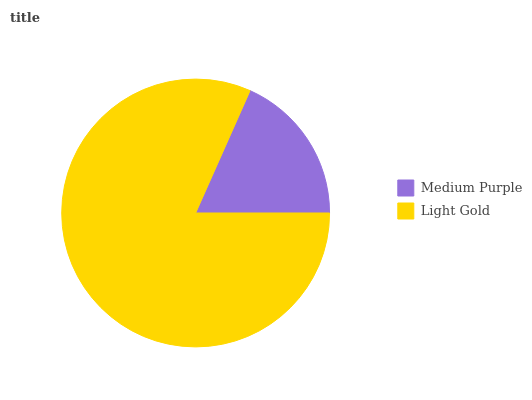Is Medium Purple the minimum?
Answer yes or no. Yes. Is Light Gold the maximum?
Answer yes or no. Yes. Is Light Gold the minimum?
Answer yes or no. No. Is Light Gold greater than Medium Purple?
Answer yes or no. Yes. Is Medium Purple less than Light Gold?
Answer yes or no. Yes. Is Medium Purple greater than Light Gold?
Answer yes or no. No. Is Light Gold less than Medium Purple?
Answer yes or no. No. Is Light Gold the high median?
Answer yes or no. Yes. Is Medium Purple the low median?
Answer yes or no. Yes. Is Medium Purple the high median?
Answer yes or no. No. Is Light Gold the low median?
Answer yes or no. No. 